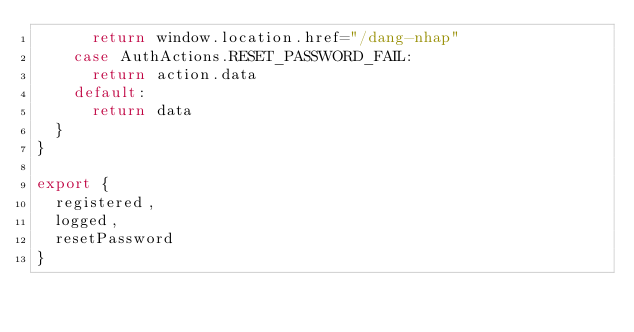Convert code to text. <code><loc_0><loc_0><loc_500><loc_500><_JavaScript_>      return window.location.href="/dang-nhap"
    case AuthActions.RESET_PASSWORD_FAIL:
      return action.data
    default:
      return data
  }
}

export {
  registered,
  logged,
  resetPassword
}</code> 